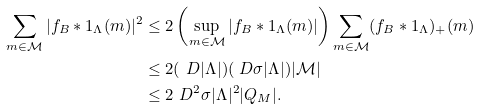Convert formula to latex. <formula><loc_0><loc_0><loc_500><loc_500>\sum _ { m \in \mathcal { M } } | f _ { B } * 1 _ { \Lambda } ( m ) | ^ { 2 } & \leq 2 \left ( \sup _ { m \in \mathcal { M } } | f _ { B } * 1 _ { \Lambda } ( m ) | \right ) \sum _ { m \in \mathcal { M } } ( f _ { B } * 1 _ { \Lambda } ) _ { + } ( m ) \\ & \leq 2 ( \ D | \Lambda | ) ( \ D \sigma | \Lambda | ) | \mathcal { M } | \\ & \leq 2 \ D ^ { 2 } \sigma | \Lambda | ^ { 2 } | Q _ { M } | .</formula> 